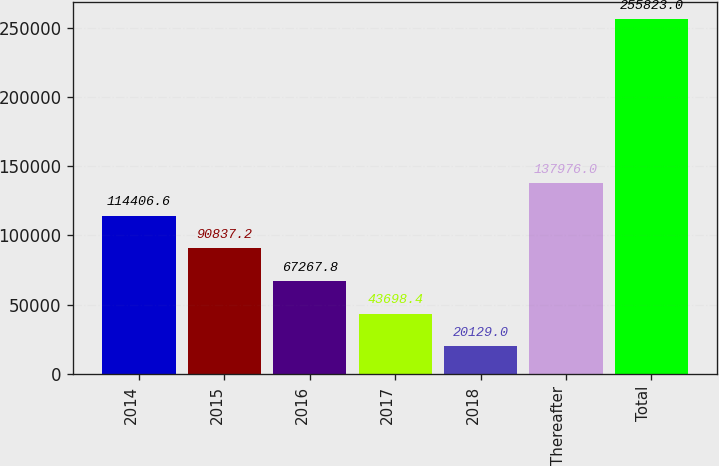<chart> <loc_0><loc_0><loc_500><loc_500><bar_chart><fcel>2014<fcel>2015<fcel>2016<fcel>2017<fcel>2018<fcel>Thereafter<fcel>Total<nl><fcel>114407<fcel>90837.2<fcel>67267.8<fcel>43698.4<fcel>20129<fcel>137976<fcel>255823<nl></chart> 